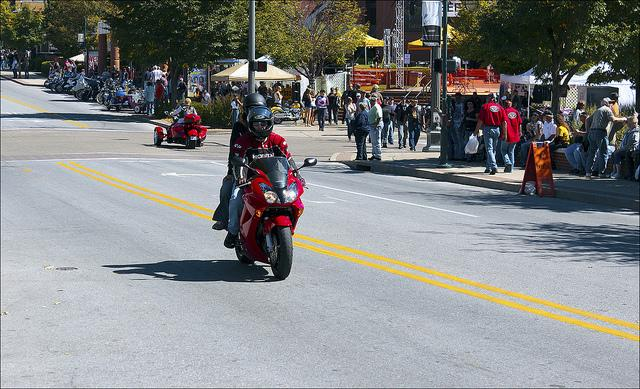What type of vehicles are most shown here? motorcycles 